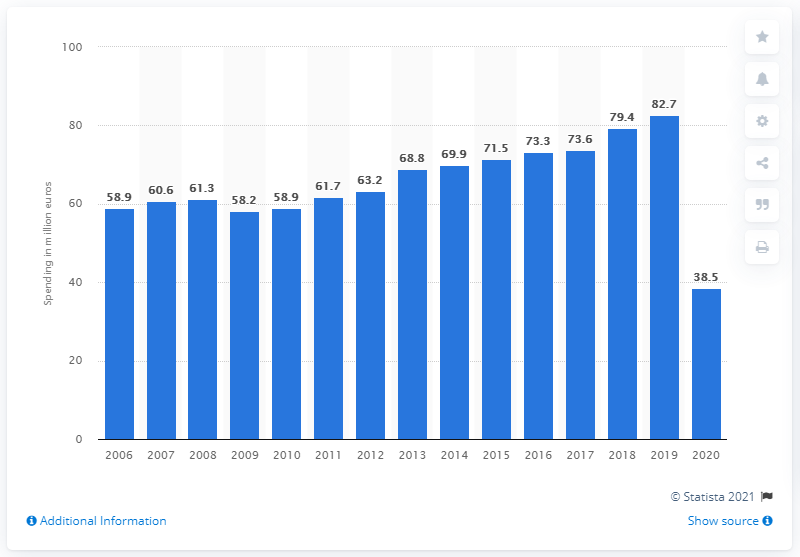Give some essential details in this illustration. German tourists spent a total of 38.5 billion U.S. dollars in 2020. In 2006, the amount of money spent by German tourists on trips abroad was 82.7 billion euros. 